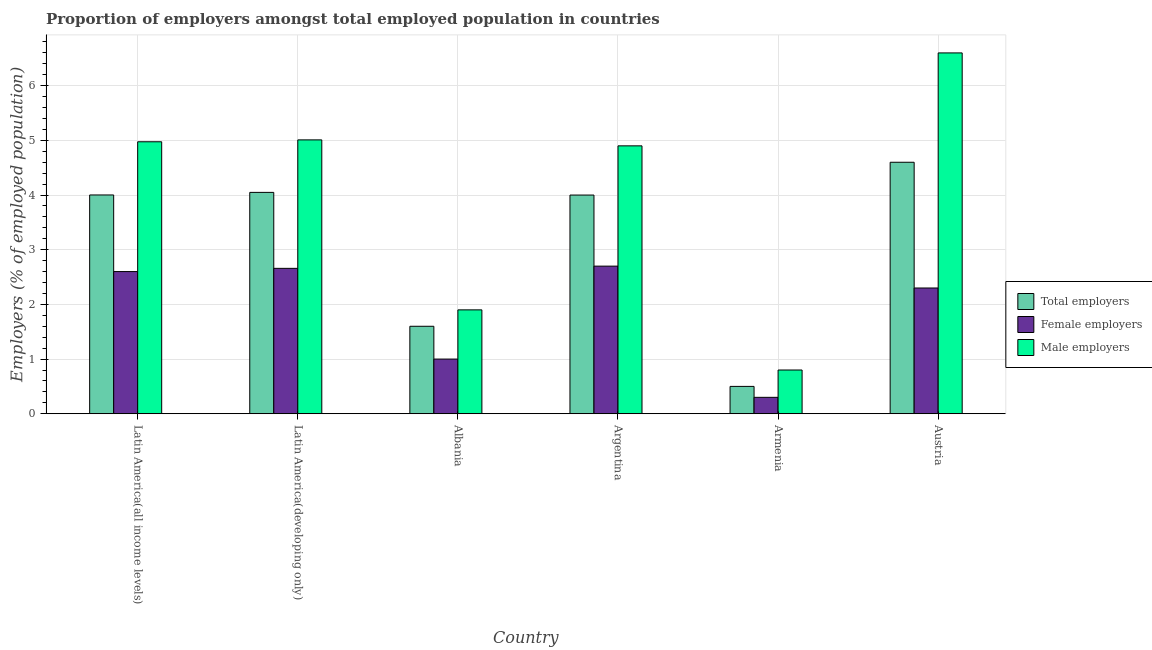Are the number of bars per tick equal to the number of legend labels?
Your answer should be compact. Yes. Are the number of bars on each tick of the X-axis equal?
Your answer should be compact. Yes. How many bars are there on the 5th tick from the right?
Ensure brevity in your answer.  3. What is the label of the 5th group of bars from the left?
Give a very brief answer. Armenia. In how many cases, is the number of bars for a given country not equal to the number of legend labels?
Your response must be concise. 0. What is the percentage of male employers in Armenia?
Give a very brief answer. 0.8. Across all countries, what is the maximum percentage of female employers?
Offer a very short reply. 2.7. Across all countries, what is the minimum percentage of female employers?
Keep it short and to the point. 0.3. In which country was the percentage of male employers minimum?
Your answer should be very brief. Armenia. What is the total percentage of total employers in the graph?
Offer a very short reply. 18.75. What is the difference between the percentage of male employers in Albania and that in Latin America(developing only)?
Your answer should be very brief. -3.11. What is the difference between the percentage of female employers in Latin America(developing only) and the percentage of total employers in Armenia?
Provide a short and direct response. 2.16. What is the average percentage of total employers per country?
Make the answer very short. 3.13. What is the difference between the percentage of female employers and percentage of total employers in Albania?
Your response must be concise. -0.6. In how many countries, is the percentage of female employers greater than 3.2 %?
Your answer should be very brief. 0. What is the ratio of the percentage of female employers in Argentina to that in Latin America(developing only)?
Provide a short and direct response. 1.02. Is the percentage of total employers in Albania less than that in Argentina?
Offer a terse response. Yes. Is the difference between the percentage of female employers in Argentina and Austria greater than the difference between the percentage of male employers in Argentina and Austria?
Give a very brief answer. Yes. What is the difference between the highest and the second highest percentage of total employers?
Make the answer very short. 0.55. What is the difference between the highest and the lowest percentage of total employers?
Offer a terse response. 4.1. In how many countries, is the percentage of female employers greater than the average percentage of female employers taken over all countries?
Offer a terse response. 4. Is the sum of the percentage of female employers in Armenia and Latin America(developing only) greater than the maximum percentage of total employers across all countries?
Offer a terse response. No. What does the 3rd bar from the left in Latin America(all income levels) represents?
Ensure brevity in your answer.  Male employers. What does the 3rd bar from the right in Argentina represents?
Offer a terse response. Total employers. How many bars are there?
Your answer should be very brief. 18. How many countries are there in the graph?
Your answer should be compact. 6. What is the difference between two consecutive major ticks on the Y-axis?
Provide a short and direct response. 1. Are the values on the major ticks of Y-axis written in scientific E-notation?
Your answer should be compact. No. Does the graph contain any zero values?
Keep it short and to the point. No. How are the legend labels stacked?
Keep it short and to the point. Vertical. What is the title of the graph?
Give a very brief answer. Proportion of employers amongst total employed population in countries. What is the label or title of the Y-axis?
Ensure brevity in your answer.  Employers (% of employed population). What is the Employers (% of employed population) of Total employers in Latin America(all income levels)?
Provide a short and direct response. 4. What is the Employers (% of employed population) in Female employers in Latin America(all income levels)?
Ensure brevity in your answer.  2.6. What is the Employers (% of employed population) in Male employers in Latin America(all income levels)?
Make the answer very short. 4.97. What is the Employers (% of employed population) in Total employers in Latin America(developing only)?
Your answer should be compact. 4.05. What is the Employers (% of employed population) of Female employers in Latin America(developing only)?
Your answer should be very brief. 2.66. What is the Employers (% of employed population) of Male employers in Latin America(developing only)?
Ensure brevity in your answer.  5.01. What is the Employers (% of employed population) in Total employers in Albania?
Ensure brevity in your answer.  1.6. What is the Employers (% of employed population) of Female employers in Albania?
Offer a very short reply. 1. What is the Employers (% of employed population) of Male employers in Albania?
Ensure brevity in your answer.  1.9. What is the Employers (% of employed population) of Total employers in Argentina?
Make the answer very short. 4. What is the Employers (% of employed population) of Female employers in Argentina?
Your response must be concise. 2.7. What is the Employers (% of employed population) of Male employers in Argentina?
Your answer should be compact. 4.9. What is the Employers (% of employed population) in Female employers in Armenia?
Provide a succinct answer. 0.3. What is the Employers (% of employed population) in Male employers in Armenia?
Ensure brevity in your answer.  0.8. What is the Employers (% of employed population) in Total employers in Austria?
Keep it short and to the point. 4.6. What is the Employers (% of employed population) of Female employers in Austria?
Offer a very short reply. 2.3. What is the Employers (% of employed population) in Male employers in Austria?
Offer a very short reply. 6.6. Across all countries, what is the maximum Employers (% of employed population) of Total employers?
Keep it short and to the point. 4.6. Across all countries, what is the maximum Employers (% of employed population) of Female employers?
Your answer should be very brief. 2.7. Across all countries, what is the maximum Employers (% of employed population) in Male employers?
Ensure brevity in your answer.  6.6. Across all countries, what is the minimum Employers (% of employed population) of Female employers?
Give a very brief answer. 0.3. Across all countries, what is the minimum Employers (% of employed population) in Male employers?
Keep it short and to the point. 0.8. What is the total Employers (% of employed population) in Total employers in the graph?
Ensure brevity in your answer.  18.75. What is the total Employers (% of employed population) in Female employers in the graph?
Offer a terse response. 11.56. What is the total Employers (% of employed population) in Male employers in the graph?
Ensure brevity in your answer.  24.18. What is the difference between the Employers (% of employed population) in Total employers in Latin America(all income levels) and that in Latin America(developing only)?
Offer a terse response. -0.05. What is the difference between the Employers (% of employed population) in Female employers in Latin America(all income levels) and that in Latin America(developing only)?
Give a very brief answer. -0.06. What is the difference between the Employers (% of employed population) in Male employers in Latin America(all income levels) and that in Latin America(developing only)?
Provide a short and direct response. -0.03. What is the difference between the Employers (% of employed population) in Total employers in Latin America(all income levels) and that in Albania?
Ensure brevity in your answer.  2.4. What is the difference between the Employers (% of employed population) of Female employers in Latin America(all income levels) and that in Albania?
Ensure brevity in your answer.  1.6. What is the difference between the Employers (% of employed population) in Male employers in Latin America(all income levels) and that in Albania?
Your response must be concise. 3.07. What is the difference between the Employers (% of employed population) of Total employers in Latin America(all income levels) and that in Argentina?
Provide a short and direct response. 0. What is the difference between the Employers (% of employed population) of Female employers in Latin America(all income levels) and that in Argentina?
Provide a short and direct response. -0.1. What is the difference between the Employers (% of employed population) in Male employers in Latin America(all income levels) and that in Argentina?
Make the answer very short. 0.07. What is the difference between the Employers (% of employed population) in Total employers in Latin America(all income levels) and that in Armenia?
Offer a very short reply. 3.5. What is the difference between the Employers (% of employed population) of Female employers in Latin America(all income levels) and that in Armenia?
Give a very brief answer. 2.3. What is the difference between the Employers (% of employed population) in Male employers in Latin America(all income levels) and that in Armenia?
Provide a short and direct response. 4.17. What is the difference between the Employers (% of employed population) of Total employers in Latin America(all income levels) and that in Austria?
Make the answer very short. -0.6. What is the difference between the Employers (% of employed population) of Female employers in Latin America(all income levels) and that in Austria?
Your response must be concise. 0.3. What is the difference between the Employers (% of employed population) of Male employers in Latin America(all income levels) and that in Austria?
Provide a short and direct response. -1.63. What is the difference between the Employers (% of employed population) in Total employers in Latin America(developing only) and that in Albania?
Make the answer very short. 2.45. What is the difference between the Employers (% of employed population) of Female employers in Latin America(developing only) and that in Albania?
Give a very brief answer. 1.66. What is the difference between the Employers (% of employed population) in Male employers in Latin America(developing only) and that in Albania?
Your answer should be compact. 3.11. What is the difference between the Employers (% of employed population) in Total employers in Latin America(developing only) and that in Argentina?
Keep it short and to the point. 0.05. What is the difference between the Employers (% of employed population) in Female employers in Latin America(developing only) and that in Argentina?
Make the answer very short. -0.04. What is the difference between the Employers (% of employed population) in Male employers in Latin America(developing only) and that in Argentina?
Offer a terse response. 0.11. What is the difference between the Employers (% of employed population) in Total employers in Latin America(developing only) and that in Armenia?
Make the answer very short. 3.55. What is the difference between the Employers (% of employed population) of Female employers in Latin America(developing only) and that in Armenia?
Provide a succinct answer. 2.36. What is the difference between the Employers (% of employed population) of Male employers in Latin America(developing only) and that in Armenia?
Give a very brief answer. 4.21. What is the difference between the Employers (% of employed population) in Total employers in Latin America(developing only) and that in Austria?
Ensure brevity in your answer.  -0.55. What is the difference between the Employers (% of employed population) in Female employers in Latin America(developing only) and that in Austria?
Provide a short and direct response. 0.36. What is the difference between the Employers (% of employed population) of Male employers in Latin America(developing only) and that in Austria?
Keep it short and to the point. -1.59. What is the difference between the Employers (% of employed population) in Total employers in Albania and that in Argentina?
Provide a succinct answer. -2.4. What is the difference between the Employers (% of employed population) in Female employers in Albania and that in Argentina?
Offer a very short reply. -1.7. What is the difference between the Employers (% of employed population) of Total employers in Albania and that in Armenia?
Keep it short and to the point. 1.1. What is the difference between the Employers (% of employed population) of Female employers in Albania and that in Armenia?
Your answer should be very brief. 0.7. What is the difference between the Employers (% of employed population) in Male employers in Albania and that in Armenia?
Your response must be concise. 1.1. What is the difference between the Employers (% of employed population) of Total employers in Albania and that in Austria?
Ensure brevity in your answer.  -3. What is the difference between the Employers (% of employed population) of Female employers in Albania and that in Austria?
Keep it short and to the point. -1.3. What is the difference between the Employers (% of employed population) of Male employers in Albania and that in Austria?
Offer a very short reply. -4.7. What is the difference between the Employers (% of employed population) in Total employers in Argentina and that in Austria?
Make the answer very short. -0.6. What is the difference between the Employers (% of employed population) in Female employers in Argentina and that in Austria?
Give a very brief answer. 0.4. What is the difference between the Employers (% of employed population) in Female employers in Armenia and that in Austria?
Offer a terse response. -2. What is the difference between the Employers (% of employed population) of Total employers in Latin America(all income levels) and the Employers (% of employed population) of Female employers in Latin America(developing only)?
Offer a terse response. 1.34. What is the difference between the Employers (% of employed population) of Total employers in Latin America(all income levels) and the Employers (% of employed population) of Male employers in Latin America(developing only)?
Offer a terse response. -1.01. What is the difference between the Employers (% of employed population) of Female employers in Latin America(all income levels) and the Employers (% of employed population) of Male employers in Latin America(developing only)?
Your response must be concise. -2.41. What is the difference between the Employers (% of employed population) of Total employers in Latin America(all income levels) and the Employers (% of employed population) of Female employers in Albania?
Give a very brief answer. 3. What is the difference between the Employers (% of employed population) of Total employers in Latin America(all income levels) and the Employers (% of employed population) of Male employers in Albania?
Your answer should be compact. 2.1. What is the difference between the Employers (% of employed population) in Female employers in Latin America(all income levels) and the Employers (% of employed population) in Male employers in Albania?
Give a very brief answer. 0.7. What is the difference between the Employers (% of employed population) of Total employers in Latin America(all income levels) and the Employers (% of employed population) of Female employers in Argentina?
Your answer should be compact. 1.3. What is the difference between the Employers (% of employed population) of Total employers in Latin America(all income levels) and the Employers (% of employed population) of Male employers in Argentina?
Your answer should be compact. -0.9. What is the difference between the Employers (% of employed population) of Female employers in Latin America(all income levels) and the Employers (% of employed population) of Male employers in Argentina?
Ensure brevity in your answer.  -2.3. What is the difference between the Employers (% of employed population) in Total employers in Latin America(all income levels) and the Employers (% of employed population) in Female employers in Armenia?
Your answer should be very brief. 3.7. What is the difference between the Employers (% of employed population) in Total employers in Latin America(all income levels) and the Employers (% of employed population) in Male employers in Armenia?
Offer a terse response. 3.2. What is the difference between the Employers (% of employed population) in Female employers in Latin America(all income levels) and the Employers (% of employed population) in Male employers in Armenia?
Your answer should be very brief. 1.8. What is the difference between the Employers (% of employed population) of Total employers in Latin America(all income levels) and the Employers (% of employed population) of Female employers in Austria?
Provide a succinct answer. 1.7. What is the difference between the Employers (% of employed population) of Total employers in Latin America(all income levels) and the Employers (% of employed population) of Male employers in Austria?
Make the answer very short. -2.6. What is the difference between the Employers (% of employed population) in Female employers in Latin America(all income levels) and the Employers (% of employed population) in Male employers in Austria?
Keep it short and to the point. -4. What is the difference between the Employers (% of employed population) of Total employers in Latin America(developing only) and the Employers (% of employed population) of Female employers in Albania?
Provide a succinct answer. 3.05. What is the difference between the Employers (% of employed population) in Total employers in Latin America(developing only) and the Employers (% of employed population) in Male employers in Albania?
Provide a succinct answer. 2.15. What is the difference between the Employers (% of employed population) of Female employers in Latin America(developing only) and the Employers (% of employed population) of Male employers in Albania?
Your answer should be compact. 0.76. What is the difference between the Employers (% of employed population) of Total employers in Latin America(developing only) and the Employers (% of employed population) of Female employers in Argentina?
Keep it short and to the point. 1.35. What is the difference between the Employers (% of employed population) of Total employers in Latin America(developing only) and the Employers (% of employed population) of Male employers in Argentina?
Provide a short and direct response. -0.85. What is the difference between the Employers (% of employed population) of Female employers in Latin America(developing only) and the Employers (% of employed population) of Male employers in Argentina?
Keep it short and to the point. -2.24. What is the difference between the Employers (% of employed population) of Total employers in Latin America(developing only) and the Employers (% of employed population) of Female employers in Armenia?
Keep it short and to the point. 3.75. What is the difference between the Employers (% of employed population) in Total employers in Latin America(developing only) and the Employers (% of employed population) in Male employers in Armenia?
Offer a terse response. 3.25. What is the difference between the Employers (% of employed population) of Female employers in Latin America(developing only) and the Employers (% of employed population) of Male employers in Armenia?
Ensure brevity in your answer.  1.86. What is the difference between the Employers (% of employed population) of Total employers in Latin America(developing only) and the Employers (% of employed population) of Female employers in Austria?
Provide a short and direct response. 1.75. What is the difference between the Employers (% of employed population) in Total employers in Latin America(developing only) and the Employers (% of employed population) in Male employers in Austria?
Your answer should be very brief. -2.55. What is the difference between the Employers (% of employed population) of Female employers in Latin America(developing only) and the Employers (% of employed population) of Male employers in Austria?
Your answer should be very brief. -3.94. What is the difference between the Employers (% of employed population) of Female employers in Albania and the Employers (% of employed population) of Male employers in Armenia?
Provide a short and direct response. 0.2. What is the difference between the Employers (% of employed population) in Total employers in Albania and the Employers (% of employed population) in Female employers in Austria?
Your response must be concise. -0.7. What is the difference between the Employers (% of employed population) in Total employers in Albania and the Employers (% of employed population) in Male employers in Austria?
Your answer should be very brief. -5. What is the difference between the Employers (% of employed population) of Total employers in Argentina and the Employers (% of employed population) of Female employers in Armenia?
Your answer should be compact. 3.7. What is the difference between the Employers (% of employed population) of Total employers in Argentina and the Employers (% of employed population) of Male employers in Armenia?
Offer a very short reply. 3.2. What is the difference between the Employers (% of employed population) in Total employers in Argentina and the Employers (% of employed population) in Female employers in Austria?
Give a very brief answer. 1.7. What is the difference between the Employers (% of employed population) of Total employers in Armenia and the Employers (% of employed population) of Male employers in Austria?
Ensure brevity in your answer.  -6.1. What is the difference between the Employers (% of employed population) of Female employers in Armenia and the Employers (% of employed population) of Male employers in Austria?
Keep it short and to the point. -6.3. What is the average Employers (% of employed population) of Total employers per country?
Offer a terse response. 3.13. What is the average Employers (% of employed population) of Female employers per country?
Give a very brief answer. 1.93. What is the average Employers (% of employed population) of Male employers per country?
Provide a succinct answer. 4.03. What is the difference between the Employers (% of employed population) in Total employers and Employers (% of employed population) in Female employers in Latin America(all income levels)?
Make the answer very short. 1.4. What is the difference between the Employers (% of employed population) in Total employers and Employers (% of employed population) in Male employers in Latin America(all income levels)?
Provide a succinct answer. -0.97. What is the difference between the Employers (% of employed population) of Female employers and Employers (% of employed population) of Male employers in Latin America(all income levels)?
Provide a succinct answer. -2.37. What is the difference between the Employers (% of employed population) in Total employers and Employers (% of employed population) in Female employers in Latin America(developing only)?
Your response must be concise. 1.39. What is the difference between the Employers (% of employed population) in Total employers and Employers (% of employed population) in Male employers in Latin America(developing only)?
Your answer should be compact. -0.96. What is the difference between the Employers (% of employed population) of Female employers and Employers (% of employed population) of Male employers in Latin America(developing only)?
Ensure brevity in your answer.  -2.35. What is the difference between the Employers (% of employed population) of Total employers and Employers (% of employed population) of Male employers in Albania?
Offer a terse response. -0.3. What is the difference between the Employers (% of employed population) of Total employers and Employers (% of employed population) of Female employers in Argentina?
Ensure brevity in your answer.  1.3. What is the difference between the Employers (% of employed population) of Total employers and Employers (% of employed population) of Male employers in Argentina?
Provide a succinct answer. -0.9. What is the difference between the Employers (% of employed population) of Total employers and Employers (% of employed population) of Female employers in Armenia?
Offer a very short reply. 0.2. What is the difference between the Employers (% of employed population) of Total employers and Employers (% of employed population) of Male employers in Armenia?
Give a very brief answer. -0.3. What is the difference between the Employers (% of employed population) of Female employers and Employers (% of employed population) of Male employers in Armenia?
Provide a succinct answer. -0.5. What is the difference between the Employers (% of employed population) in Total employers and Employers (% of employed population) in Female employers in Austria?
Your answer should be compact. 2.3. What is the difference between the Employers (% of employed population) in Total employers and Employers (% of employed population) in Male employers in Austria?
Make the answer very short. -2. What is the difference between the Employers (% of employed population) in Female employers and Employers (% of employed population) in Male employers in Austria?
Ensure brevity in your answer.  -4.3. What is the ratio of the Employers (% of employed population) of Total employers in Latin America(all income levels) to that in Latin America(developing only)?
Ensure brevity in your answer.  0.99. What is the ratio of the Employers (% of employed population) in Female employers in Latin America(all income levels) to that in Latin America(developing only)?
Provide a short and direct response. 0.98. What is the ratio of the Employers (% of employed population) of Male employers in Latin America(all income levels) to that in Latin America(developing only)?
Offer a terse response. 0.99. What is the ratio of the Employers (% of employed population) of Total employers in Latin America(all income levels) to that in Albania?
Your answer should be very brief. 2.5. What is the ratio of the Employers (% of employed population) in Female employers in Latin America(all income levels) to that in Albania?
Your response must be concise. 2.6. What is the ratio of the Employers (% of employed population) of Male employers in Latin America(all income levels) to that in Albania?
Provide a succinct answer. 2.62. What is the ratio of the Employers (% of employed population) of Female employers in Latin America(all income levels) to that in Argentina?
Keep it short and to the point. 0.96. What is the ratio of the Employers (% of employed population) of Male employers in Latin America(all income levels) to that in Argentina?
Offer a terse response. 1.02. What is the ratio of the Employers (% of employed population) in Total employers in Latin America(all income levels) to that in Armenia?
Give a very brief answer. 8. What is the ratio of the Employers (% of employed population) of Female employers in Latin America(all income levels) to that in Armenia?
Keep it short and to the point. 8.67. What is the ratio of the Employers (% of employed population) of Male employers in Latin America(all income levels) to that in Armenia?
Your answer should be compact. 6.22. What is the ratio of the Employers (% of employed population) of Total employers in Latin America(all income levels) to that in Austria?
Give a very brief answer. 0.87. What is the ratio of the Employers (% of employed population) in Female employers in Latin America(all income levels) to that in Austria?
Your answer should be compact. 1.13. What is the ratio of the Employers (% of employed population) of Male employers in Latin America(all income levels) to that in Austria?
Your response must be concise. 0.75. What is the ratio of the Employers (% of employed population) of Total employers in Latin America(developing only) to that in Albania?
Offer a very short reply. 2.53. What is the ratio of the Employers (% of employed population) of Female employers in Latin America(developing only) to that in Albania?
Keep it short and to the point. 2.66. What is the ratio of the Employers (% of employed population) in Male employers in Latin America(developing only) to that in Albania?
Offer a very short reply. 2.64. What is the ratio of the Employers (% of employed population) of Total employers in Latin America(developing only) to that in Argentina?
Provide a short and direct response. 1.01. What is the ratio of the Employers (% of employed population) in Female employers in Latin America(developing only) to that in Argentina?
Offer a terse response. 0.98. What is the ratio of the Employers (% of employed population) in Male employers in Latin America(developing only) to that in Argentina?
Keep it short and to the point. 1.02. What is the ratio of the Employers (% of employed population) of Total employers in Latin America(developing only) to that in Armenia?
Provide a short and direct response. 8.1. What is the ratio of the Employers (% of employed population) of Female employers in Latin America(developing only) to that in Armenia?
Ensure brevity in your answer.  8.86. What is the ratio of the Employers (% of employed population) in Male employers in Latin America(developing only) to that in Armenia?
Keep it short and to the point. 6.26. What is the ratio of the Employers (% of employed population) of Total employers in Latin America(developing only) to that in Austria?
Keep it short and to the point. 0.88. What is the ratio of the Employers (% of employed population) of Female employers in Latin America(developing only) to that in Austria?
Give a very brief answer. 1.16. What is the ratio of the Employers (% of employed population) of Male employers in Latin America(developing only) to that in Austria?
Offer a very short reply. 0.76. What is the ratio of the Employers (% of employed population) of Total employers in Albania to that in Argentina?
Your answer should be compact. 0.4. What is the ratio of the Employers (% of employed population) of Female employers in Albania to that in Argentina?
Ensure brevity in your answer.  0.37. What is the ratio of the Employers (% of employed population) in Male employers in Albania to that in Argentina?
Your response must be concise. 0.39. What is the ratio of the Employers (% of employed population) in Total employers in Albania to that in Armenia?
Your answer should be compact. 3.2. What is the ratio of the Employers (% of employed population) in Male employers in Albania to that in Armenia?
Give a very brief answer. 2.38. What is the ratio of the Employers (% of employed population) of Total employers in Albania to that in Austria?
Provide a succinct answer. 0.35. What is the ratio of the Employers (% of employed population) in Female employers in Albania to that in Austria?
Offer a very short reply. 0.43. What is the ratio of the Employers (% of employed population) in Male employers in Albania to that in Austria?
Provide a short and direct response. 0.29. What is the ratio of the Employers (% of employed population) of Male employers in Argentina to that in Armenia?
Your response must be concise. 6.12. What is the ratio of the Employers (% of employed population) of Total employers in Argentina to that in Austria?
Give a very brief answer. 0.87. What is the ratio of the Employers (% of employed population) of Female employers in Argentina to that in Austria?
Give a very brief answer. 1.17. What is the ratio of the Employers (% of employed population) of Male employers in Argentina to that in Austria?
Offer a terse response. 0.74. What is the ratio of the Employers (% of employed population) in Total employers in Armenia to that in Austria?
Offer a terse response. 0.11. What is the ratio of the Employers (% of employed population) in Female employers in Armenia to that in Austria?
Keep it short and to the point. 0.13. What is the ratio of the Employers (% of employed population) in Male employers in Armenia to that in Austria?
Keep it short and to the point. 0.12. What is the difference between the highest and the second highest Employers (% of employed population) in Total employers?
Provide a succinct answer. 0.55. What is the difference between the highest and the second highest Employers (% of employed population) of Female employers?
Offer a terse response. 0.04. What is the difference between the highest and the second highest Employers (% of employed population) in Male employers?
Make the answer very short. 1.59. What is the difference between the highest and the lowest Employers (% of employed population) of Male employers?
Keep it short and to the point. 5.8. 